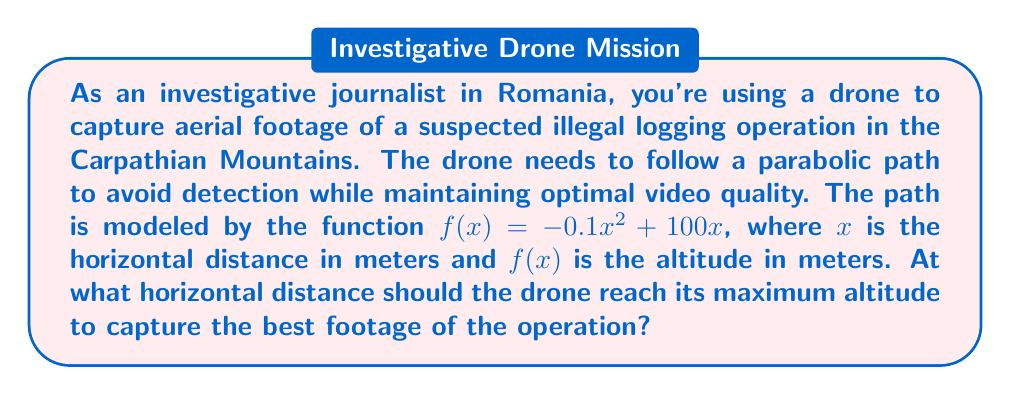What is the answer to this math problem? To find the maximum altitude of the drone's path, we need to determine the vertex of the parabola described by the function $f(x)=-0.1x^2+100x$. The vertex represents the highest point of the parabola.

For a quadratic function in the form $f(x)=ax^2+bx+c$, the x-coordinate of the vertex is given by $x=-\frac{b}{2a}$.

In our case:
$a=-0.1$
$b=100$
$c=0$

Let's calculate the x-coordinate of the vertex:

$$x=-\frac{b}{2a}=-\frac{100}{2(-0.1)}=-\frac{100}{-0.2}=500$$

To verify this result, we can use the first derivative test:

1) Find the first derivative: $f'(x)=-0.2x+100$
2) Set $f'(x)=0$ and solve for x:
   $-0.2x+100=0$
   $-0.2x=-100$
   $x=500$

This confirms our calculation.

The horizontal distance at which the drone reaches its maximum altitude is 500 meters from the starting point.
Answer: The drone should reach its maximum altitude at a horizontal distance of 500 meters. 